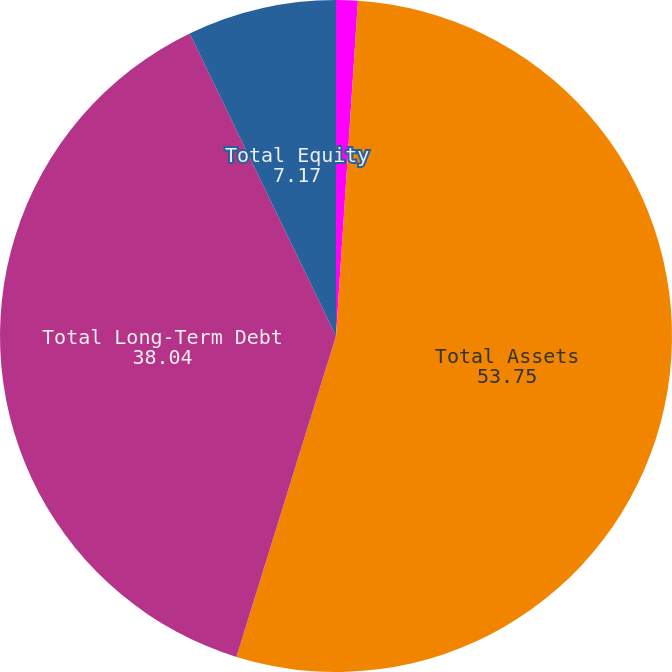Convert chart. <chart><loc_0><loc_0><loc_500><loc_500><pie_chart><fcel>Cash and Cash Equivalents<fcel>Total Assets<fcel>Total Long-Term Debt<fcel>Total Equity<nl><fcel>1.04%<fcel>53.75%<fcel>38.04%<fcel>7.17%<nl></chart> 